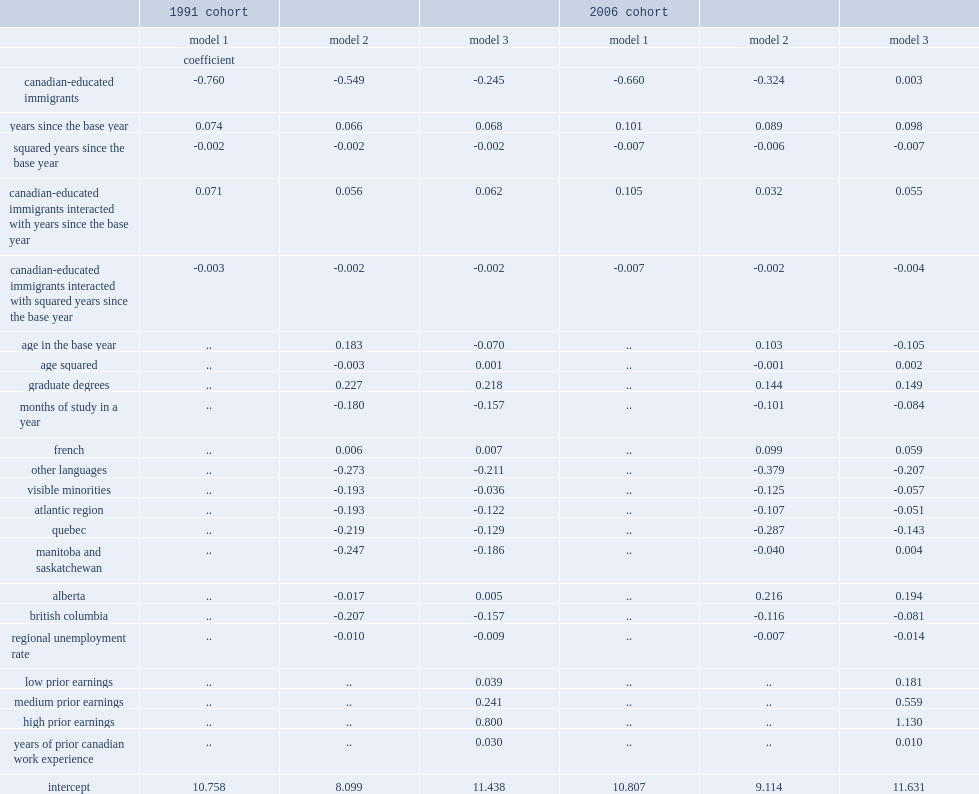What is the initial earnings gap of ce immigrants in 1991 cohort when the sociodemographic control variables are added for model 2? -0.549. What is the initial earnings gap of ce immigrants for model i, in 1991 cohort? -0.76. What is the initial earnings gap of ce immigrants in 1991 cohort, when variables representing work history before the base year were added for model 3? -0.245. How many log points of higher enarings in the years after the base year are associated with one year of canadian work experience before the base year in 1991 cohort? 0.03. Help me parse the entirety of this table. {'header': ['', '1991 cohort', '', '', '2006 cohort', '', ''], 'rows': [['', 'model 1', 'model 2', 'model 3', 'model 1', 'model 2', 'model 3'], ['', 'coefficient', '', '', '', '', ''], ['canadian-educated immigrants', '-0.760', '-0.549', '-0.245', '-0.660', '-0.324', '0.003'], ['years since the base year', '0.074', '0.066', '0.068', '0.101', '0.089', '0.098'], ['squared years since the base year', '-0.002', '-0.002', '-0.002', '-0.007', '-0.006', '-0.007'], ['canadian-educated immigrants interacted with years since the base year', '0.071', '0.056', '0.062', '0.105', '0.032', '0.055'], ['canadian-educated immigrants interacted with squared years since the base year', '-0.003', '-0.002', '-0.002', '-0.007', '-0.002', '-0.004'], ['age in the base year', '..', '0.183', '-0.070', '..', '0.103', '-0.105'], ['age squared', '..', '-0.003', '0.001', '..', '-0.001', '0.002'], ['graduate degrees', '..', '0.227', '0.218', '..', '0.144', '0.149'], ['months of study in a year', '..', '-0.180', '-0.157', '..', '-0.101', '-0.084'], ['french', '..', '0.006', '0.007', '..', '0.099', '0.059'], ['other languages', '..', '-0.273', '-0.211', '..', '-0.379', '-0.207'], ['visible minorities', '..', '-0.193', '-0.036', '..', '-0.125', '-0.057'], ['atlantic region', '..', '-0.193', '-0.122', '..', '-0.107', '-0.051'], ['quebec', '..', '-0.219', '-0.129', '..', '-0.287', '-0.143'], ['manitoba and saskatchewan', '..', '-0.247', '-0.186', '..', '-0.040', '0.004'], ['alberta', '..', '-0.017', '0.005', '..', '0.216', '0.194'], ['british columbia', '..', '-0.207', '-0.157', '..', '-0.116', '-0.081'], ['regional unemployment rate', '..', '-0.010', '-0.009', '..', '-0.007', '-0.014'], ['low prior earnings', '..', '..', '0.039', '..', '..', '0.181'], ['medium prior earnings', '..', '..', '0.241', '..', '..', '0.559'], ['high prior earnings', '..', '..', '0.800', '..', '..', '1.130'], ['years of prior canadian work experience', '..', '..', '0.030', '..', '..', '0.010'], ['intercept', '10.758', '8.099', '11.438', '10.807', '9.114', '11.631']]} 